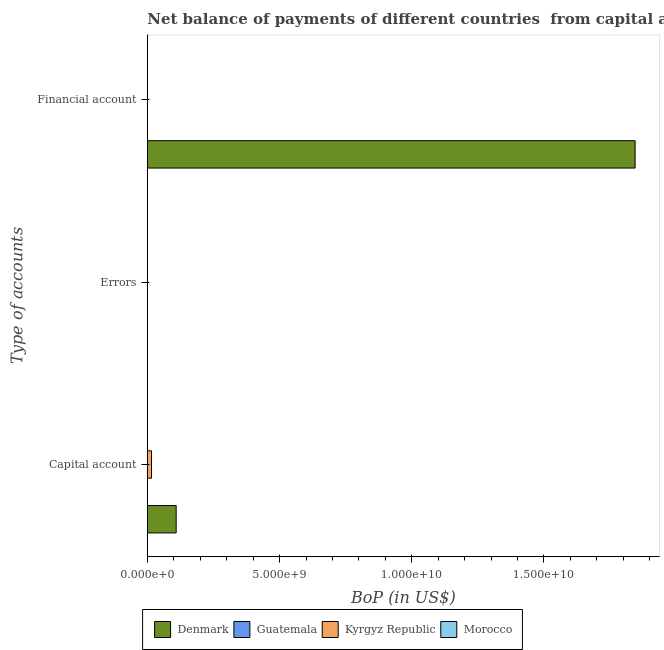How many different coloured bars are there?
Your answer should be very brief. 3. How many bars are there on the 3rd tick from the top?
Give a very brief answer. 3. What is the label of the 1st group of bars from the top?
Make the answer very short. Financial account. What is the amount of errors in Guatemala?
Offer a very short reply. 0. Across all countries, what is the maximum amount of net capital account?
Your answer should be very brief. 1.09e+09. What is the total amount of net capital account in the graph?
Offer a terse response. 1.25e+09. What is the difference between the amount of net capital account in Guatemala and that in Denmark?
Ensure brevity in your answer.  -1.09e+09. What is the difference between the amount of net capital account in Denmark and the amount of financial account in Morocco?
Give a very brief answer. 1.09e+09. What is the average amount of errors per country?
Give a very brief answer. 0. What is the difference between the amount of financial account and amount of net capital account in Denmark?
Provide a succinct answer. 1.74e+1. What is the difference between the highest and the second highest amount of net capital account?
Keep it short and to the point. 9.33e+08. What is the difference between the highest and the lowest amount of financial account?
Your response must be concise. 1.84e+1. In how many countries, is the amount of financial account greater than the average amount of financial account taken over all countries?
Ensure brevity in your answer.  1. Is the sum of the amount of net capital account in Denmark and Kyrgyz Republic greater than the maximum amount of errors across all countries?
Give a very brief answer. Yes. Is it the case that in every country, the sum of the amount of net capital account and amount of errors is greater than the amount of financial account?
Ensure brevity in your answer.  No. How many bars are there?
Give a very brief answer. 4. Are the values on the major ticks of X-axis written in scientific E-notation?
Your response must be concise. Yes. Does the graph contain any zero values?
Offer a terse response. Yes. How many legend labels are there?
Provide a short and direct response. 4. What is the title of the graph?
Offer a terse response. Net balance of payments of different countries  from capital and financial account. Does "Ireland" appear as one of the legend labels in the graph?
Your answer should be very brief. No. What is the label or title of the X-axis?
Your answer should be compact. BoP (in US$). What is the label or title of the Y-axis?
Your answer should be very brief. Type of accounts. What is the BoP (in US$) in Denmark in Capital account?
Your answer should be very brief. 1.09e+09. What is the BoP (in US$) in Guatemala in Capital account?
Offer a terse response. 2.63e+06. What is the BoP (in US$) in Kyrgyz Republic in Capital account?
Ensure brevity in your answer.  1.57e+08. What is the BoP (in US$) of Morocco in Capital account?
Provide a short and direct response. 0. What is the BoP (in US$) in Morocco in Errors?
Make the answer very short. 0. What is the BoP (in US$) of Denmark in Financial account?
Give a very brief answer. 1.84e+1. What is the BoP (in US$) of Morocco in Financial account?
Offer a terse response. 0. Across all Type of accounts, what is the maximum BoP (in US$) of Denmark?
Make the answer very short. 1.84e+1. Across all Type of accounts, what is the maximum BoP (in US$) of Guatemala?
Provide a short and direct response. 2.63e+06. Across all Type of accounts, what is the maximum BoP (in US$) in Kyrgyz Republic?
Make the answer very short. 1.57e+08. Across all Type of accounts, what is the minimum BoP (in US$) of Denmark?
Offer a terse response. 0. What is the total BoP (in US$) of Denmark in the graph?
Give a very brief answer. 1.95e+1. What is the total BoP (in US$) of Guatemala in the graph?
Provide a short and direct response. 2.63e+06. What is the total BoP (in US$) in Kyrgyz Republic in the graph?
Your response must be concise. 1.57e+08. What is the difference between the BoP (in US$) of Denmark in Capital account and that in Financial account?
Provide a short and direct response. -1.74e+1. What is the average BoP (in US$) of Denmark per Type of accounts?
Offer a very short reply. 6.51e+09. What is the average BoP (in US$) in Guatemala per Type of accounts?
Keep it short and to the point. 8.77e+05. What is the average BoP (in US$) in Kyrgyz Republic per Type of accounts?
Provide a short and direct response. 5.24e+07. What is the difference between the BoP (in US$) in Denmark and BoP (in US$) in Guatemala in Capital account?
Your answer should be very brief. 1.09e+09. What is the difference between the BoP (in US$) of Denmark and BoP (in US$) of Kyrgyz Republic in Capital account?
Offer a very short reply. 9.33e+08. What is the difference between the BoP (in US$) in Guatemala and BoP (in US$) in Kyrgyz Republic in Capital account?
Provide a short and direct response. -1.55e+08. What is the ratio of the BoP (in US$) in Denmark in Capital account to that in Financial account?
Your response must be concise. 0.06. What is the difference between the highest and the lowest BoP (in US$) in Denmark?
Make the answer very short. 1.84e+1. What is the difference between the highest and the lowest BoP (in US$) in Guatemala?
Provide a short and direct response. 2.63e+06. What is the difference between the highest and the lowest BoP (in US$) of Kyrgyz Republic?
Ensure brevity in your answer.  1.57e+08. 